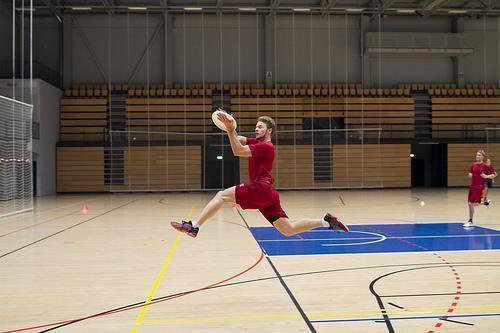How many boys are wearing red?
Give a very brief answer. 2. 